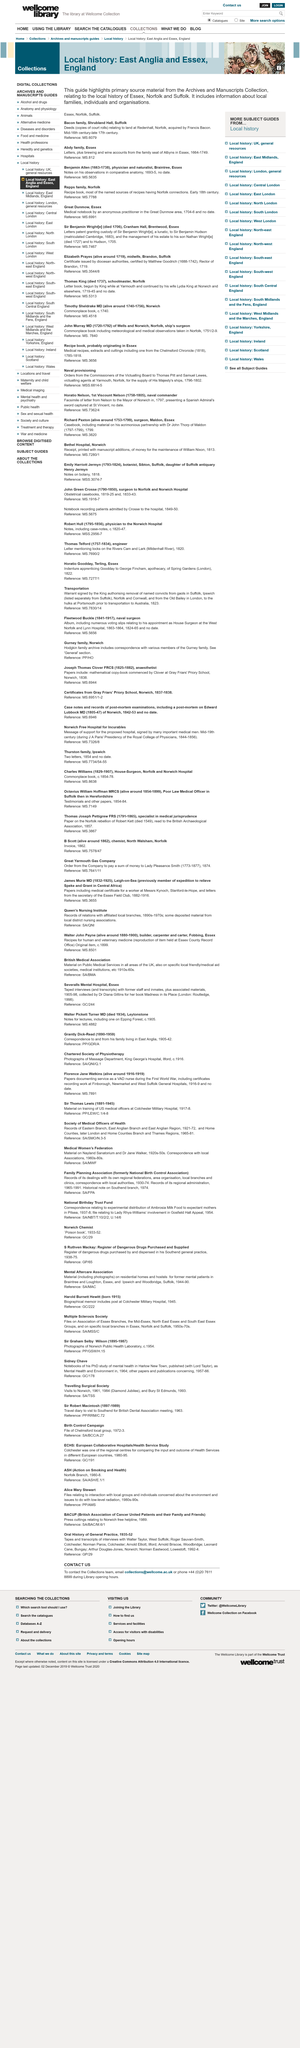Mention a couple of crucial points in this snapshot. The local history covered by this source is focused on East Anglia and Essex, England. This guide provides information about local families, individuals, and organizations. The purpose of this guide is to clarify and promote the most important and relevant primary source material from the archives and manuscripts collection. 